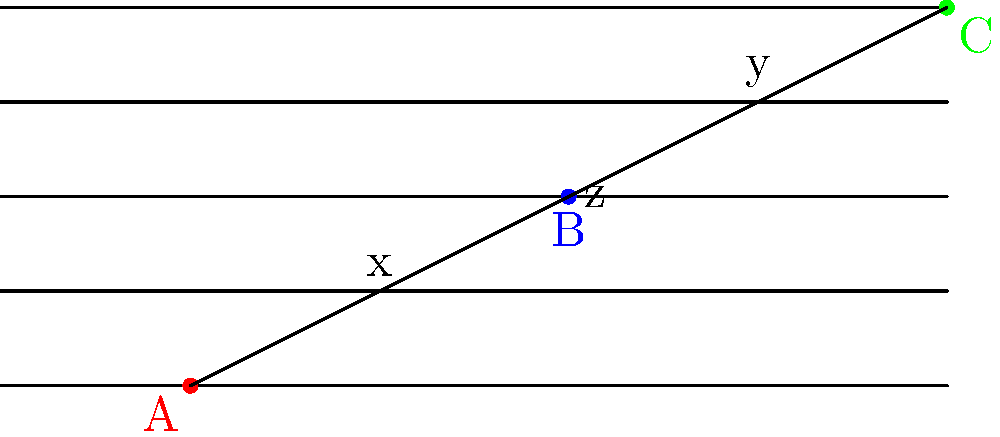In the musical staff above, three notes A, B, and C form a triangle. The distance between each staff line is constant. If the length of side x is 5 units and the length of side y is 5 units, what can be concluded about triangle ABC? Let's approach this step-by-step:

1) First, we need to understand what the given information tells us:
   - The distance between each staff line is constant.
   - Side x spans 2 staff spaces horizontally and 1 staff space vertically.
   - Side y spans 2 staff spaces horizontally and 1 staff space vertically.
   - Both sides x and y have a length of 5 units.

2) In a right triangle, we can use the Pythagorean theorem:
   $a^2 + b^2 = c^2$, where c is the hypotenuse.

3) For both sides x and y:
   $4^2 + 1^2 = 5^2$
   $16 + 1 = 25$
   This confirms that both x and y have a length of 5 units.

4) Since x and y have the same length and span the same number of staff spaces horizontally and vertically, they are congruent sides.

5) In a triangle, if two sides are congruent, the angles opposite these sides are also congruent.

6) Therefore, the angles opposite sides x and y in triangle ABC are congruent.

7) When a triangle has two congruent sides and two congruent angles, it is an isosceles triangle.

Thus, we can conclude that triangle ABC is an isosceles triangle.
Answer: Triangle ABC is isosceles. 